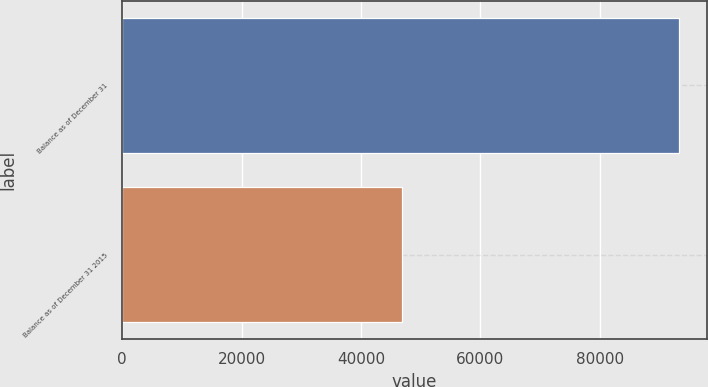<chart> <loc_0><loc_0><loc_500><loc_500><bar_chart><fcel>Balance as of December 31<fcel>Balance as of December 31 2015<nl><fcel>93267<fcel>46921<nl></chart> 